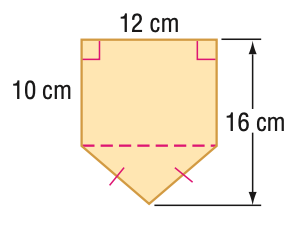Answer the mathemtical geometry problem and directly provide the correct option letter.
Question: Find the area of the figure. Round to the nearest tenth if necessary.
Choices: A: 36 B: 120 C: 156 D: 192 C 